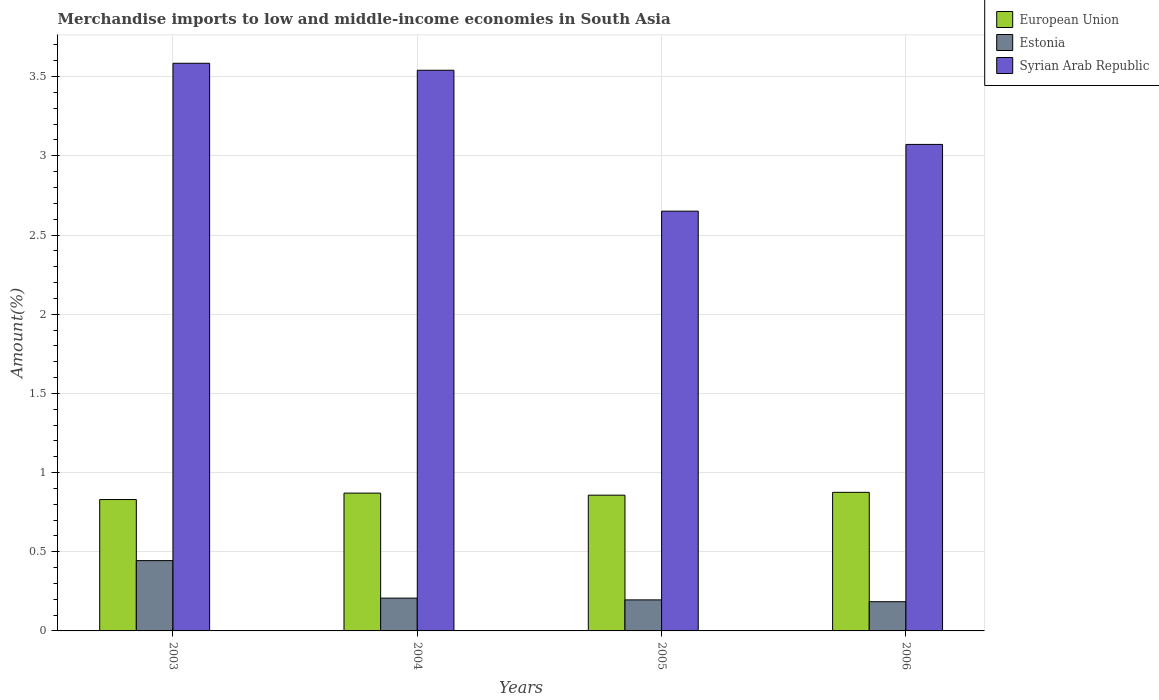Are the number of bars on each tick of the X-axis equal?
Ensure brevity in your answer.  Yes. How many bars are there on the 1st tick from the left?
Ensure brevity in your answer.  3. What is the label of the 4th group of bars from the left?
Your response must be concise. 2006. In how many cases, is the number of bars for a given year not equal to the number of legend labels?
Keep it short and to the point. 0. What is the percentage of amount earned from merchandise imports in Syrian Arab Republic in 2006?
Provide a succinct answer. 3.07. Across all years, what is the maximum percentage of amount earned from merchandise imports in Estonia?
Offer a terse response. 0.44. Across all years, what is the minimum percentage of amount earned from merchandise imports in Estonia?
Offer a terse response. 0.18. In which year was the percentage of amount earned from merchandise imports in European Union maximum?
Give a very brief answer. 2006. What is the total percentage of amount earned from merchandise imports in Estonia in the graph?
Offer a very short reply. 1.03. What is the difference between the percentage of amount earned from merchandise imports in European Union in 2003 and that in 2005?
Your answer should be very brief. -0.03. What is the difference between the percentage of amount earned from merchandise imports in Syrian Arab Republic in 2005 and the percentage of amount earned from merchandise imports in Estonia in 2006?
Keep it short and to the point. 2.47. What is the average percentage of amount earned from merchandise imports in Estonia per year?
Offer a terse response. 0.26. In the year 2005, what is the difference between the percentage of amount earned from merchandise imports in Estonia and percentage of amount earned from merchandise imports in European Union?
Give a very brief answer. -0.66. In how many years, is the percentage of amount earned from merchandise imports in European Union greater than 3.2 %?
Your answer should be compact. 0. What is the ratio of the percentage of amount earned from merchandise imports in Syrian Arab Republic in 2004 to that in 2005?
Offer a terse response. 1.34. Is the percentage of amount earned from merchandise imports in European Union in 2003 less than that in 2005?
Offer a terse response. Yes. Is the difference between the percentage of amount earned from merchandise imports in Estonia in 2003 and 2005 greater than the difference between the percentage of amount earned from merchandise imports in European Union in 2003 and 2005?
Give a very brief answer. Yes. What is the difference between the highest and the second highest percentage of amount earned from merchandise imports in Syrian Arab Republic?
Your answer should be very brief. 0.04. What is the difference between the highest and the lowest percentage of amount earned from merchandise imports in Estonia?
Your answer should be compact. 0.26. What does the 3rd bar from the left in 2005 represents?
Provide a short and direct response. Syrian Arab Republic. What does the 1st bar from the right in 2004 represents?
Provide a short and direct response. Syrian Arab Republic. Is it the case that in every year, the sum of the percentage of amount earned from merchandise imports in Estonia and percentage of amount earned from merchandise imports in European Union is greater than the percentage of amount earned from merchandise imports in Syrian Arab Republic?
Give a very brief answer. No. Are all the bars in the graph horizontal?
Provide a succinct answer. No. How many years are there in the graph?
Offer a terse response. 4. What is the difference between two consecutive major ticks on the Y-axis?
Your response must be concise. 0.5. Does the graph contain grids?
Offer a terse response. Yes. Where does the legend appear in the graph?
Your answer should be compact. Top right. How are the legend labels stacked?
Give a very brief answer. Vertical. What is the title of the graph?
Make the answer very short. Merchandise imports to low and middle-income economies in South Asia. Does "Curacao" appear as one of the legend labels in the graph?
Provide a succinct answer. No. What is the label or title of the Y-axis?
Keep it short and to the point. Amount(%). What is the Amount(%) of European Union in 2003?
Your answer should be compact. 0.83. What is the Amount(%) of Estonia in 2003?
Keep it short and to the point. 0.44. What is the Amount(%) in Syrian Arab Republic in 2003?
Your response must be concise. 3.58. What is the Amount(%) in European Union in 2004?
Give a very brief answer. 0.87. What is the Amount(%) of Estonia in 2004?
Provide a succinct answer. 0.21. What is the Amount(%) of Syrian Arab Republic in 2004?
Your answer should be compact. 3.54. What is the Amount(%) of European Union in 2005?
Give a very brief answer. 0.86. What is the Amount(%) in Estonia in 2005?
Provide a short and direct response. 0.2. What is the Amount(%) in Syrian Arab Republic in 2005?
Your response must be concise. 2.65. What is the Amount(%) in European Union in 2006?
Your answer should be compact. 0.88. What is the Amount(%) of Estonia in 2006?
Make the answer very short. 0.18. What is the Amount(%) of Syrian Arab Republic in 2006?
Provide a short and direct response. 3.07. Across all years, what is the maximum Amount(%) of European Union?
Provide a short and direct response. 0.88. Across all years, what is the maximum Amount(%) in Estonia?
Offer a very short reply. 0.44. Across all years, what is the maximum Amount(%) in Syrian Arab Republic?
Give a very brief answer. 3.58. Across all years, what is the minimum Amount(%) in European Union?
Keep it short and to the point. 0.83. Across all years, what is the minimum Amount(%) of Estonia?
Make the answer very short. 0.18. Across all years, what is the minimum Amount(%) in Syrian Arab Republic?
Ensure brevity in your answer.  2.65. What is the total Amount(%) in European Union in the graph?
Your answer should be very brief. 3.43. What is the total Amount(%) in Estonia in the graph?
Offer a very short reply. 1.03. What is the total Amount(%) of Syrian Arab Republic in the graph?
Provide a succinct answer. 12.85. What is the difference between the Amount(%) in European Union in 2003 and that in 2004?
Keep it short and to the point. -0.04. What is the difference between the Amount(%) in Estonia in 2003 and that in 2004?
Your response must be concise. 0.24. What is the difference between the Amount(%) in Syrian Arab Republic in 2003 and that in 2004?
Ensure brevity in your answer.  0.04. What is the difference between the Amount(%) of European Union in 2003 and that in 2005?
Ensure brevity in your answer.  -0.03. What is the difference between the Amount(%) in Estonia in 2003 and that in 2005?
Ensure brevity in your answer.  0.25. What is the difference between the Amount(%) in Syrian Arab Republic in 2003 and that in 2005?
Your response must be concise. 0.93. What is the difference between the Amount(%) in European Union in 2003 and that in 2006?
Provide a succinct answer. -0.05. What is the difference between the Amount(%) in Estonia in 2003 and that in 2006?
Offer a terse response. 0.26. What is the difference between the Amount(%) of Syrian Arab Republic in 2003 and that in 2006?
Your answer should be compact. 0.51. What is the difference between the Amount(%) in European Union in 2004 and that in 2005?
Your answer should be very brief. 0.01. What is the difference between the Amount(%) of Estonia in 2004 and that in 2005?
Keep it short and to the point. 0.01. What is the difference between the Amount(%) of Syrian Arab Republic in 2004 and that in 2005?
Ensure brevity in your answer.  0.89. What is the difference between the Amount(%) of European Union in 2004 and that in 2006?
Your answer should be compact. -0. What is the difference between the Amount(%) in Estonia in 2004 and that in 2006?
Offer a very short reply. 0.02. What is the difference between the Amount(%) in Syrian Arab Republic in 2004 and that in 2006?
Provide a short and direct response. 0.47. What is the difference between the Amount(%) of European Union in 2005 and that in 2006?
Your answer should be compact. -0.02. What is the difference between the Amount(%) in Estonia in 2005 and that in 2006?
Offer a very short reply. 0.01. What is the difference between the Amount(%) of Syrian Arab Republic in 2005 and that in 2006?
Make the answer very short. -0.42. What is the difference between the Amount(%) of European Union in 2003 and the Amount(%) of Estonia in 2004?
Ensure brevity in your answer.  0.62. What is the difference between the Amount(%) of European Union in 2003 and the Amount(%) of Syrian Arab Republic in 2004?
Offer a very short reply. -2.71. What is the difference between the Amount(%) of Estonia in 2003 and the Amount(%) of Syrian Arab Republic in 2004?
Your answer should be very brief. -3.1. What is the difference between the Amount(%) in European Union in 2003 and the Amount(%) in Estonia in 2005?
Your response must be concise. 0.63. What is the difference between the Amount(%) of European Union in 2003 and the Amount(%) of Syrian Arab Republic in 2005?
Provide a short and direct response. -1.82. What is the difference between the Amount(%) of Estonia in 2003 and the Amount(%) of Syrian Arab Republic in 2005?
Keep it short and to the point. -2.21. What is the difference between the Amount(%) of European Union in 2003 and the Amount(%) of Estonia in 2006?
Your response must be concise. 0.65. What is the difference between the Amount(%) of European Union in 2003 and the Amount(%) of Syrian Arab Republic in 2006?
Ensure brevity in your answer.  -2.24. What is the difference between the Amount(%) in Estonia in 2003 and the Amount(%) in Syrian Arab Republic in 2006?
Ensure brevity in your answer.  -2.63. What is the difference between the Amount(%) of European Union in 2004 and the Amount(%) of Estonia in 2005?
Keep it short and to the point. 0.67. What is the difference between the Amount(%) of European Union in 2004 and the Amount(%) of Syrian Arab Republic in 2005?
Keep it short and to the point. -1.78. What is the difference between the Amount(%) of Estonia in 2004 and the Amount(%) of Syrian Arab Republic in 2005?
Ensure brevity in your answer.  -2.44. What is the difference between the Amount(%) of European Union in 2004 and the Amount(%) of Estonia in 2006?
Provide a succinct answer. 0.69. What is the difference between the Amount(%) in European Union in 2004 and the Amount(%) in Syrian Arab Republic in 2006?
Your response must be concise. -2.2. What is the difference between the Amount(%) of Estonia in 2004 and the Amount(%) of Syrian Arab Republic in 2006?
Provide a short and direct response. -2.87. What is the difference between the Amount(%) of European Union in 2005 and the Amount(%) of Estonia in 2006?
Your response must be concise. 0.67. What is the difference between the Amount(%) of European Union in 2005 and the Amount(%) of Syrian Arab Republic in 2006?
Offer a terse response. -2.21. What is the difference between the Amount(%) of Estonia in 2005 and the Amount(%) of Syrian Arab Republic in 2006?
Your answer should be very brief. -2.88. What is the average Amount(%) in European Union per year?
Offer a very short reply. 0.86. What is the average Amount(%) of Estonia per year?
Offer a very short reply. 0.26. What is the average Amount(%) in Syrian Arab Republic per year?
Provide a succinct answer. 3.21. In the year 2003, what is the difference between the Amount(%) of European Union and Amount(%) of Estonia?
Offer a terse response. 0.39. In the year 2003, what is the difference between the Amount(%) of European Union and Amount(%) of Syrian Arab Republic?
Your response must be concise. -2.75. In the year 2003, what is the difference between the Amount(%) in Estonia and Amount(%) in Syrian Arab Republic?
Provide a short and direct response. -3.14. In the year 2004, what is the difference between the Amount(%) of European Union and Amount(%) of Estonia?
Ensure brevity in your answer.  0.66. In the year 2004, what is the difference between the Amount(%) of European Union and Amount(%) of Syrian Arab Republic?
Ensure brevity in your answer.  -2.67. In the year 2004, what is the difference between the Amount(%) of Estonia and Amount(%) of Syrian Arab Republic?
Offer a very short reply. -3.33. In the year 2005, what is the difference between the Amount(%) of European Union and Amount(%) of Estonia?
Give a very brief answer. 0.66. In the year 2005, what is the difference between the Amount(%) of European Union and Amount(%) of Syrian Arab Republic?
Your answer should be compact. -1.79. In the year 2005, what is the difference between the Amount(%) in Estonia and Amount(%) in Syrian Arab Republic?
Your response must be concise. -2.45. In the year 2006, what is the difference between the Amount(%) in European Union and Amount(%) in Estonia?
Your answer should be compact. 0.69. In the year 2006, what is the difference between the Amount(%) of European Union and Amount(%) of Syrian Arab Republic?
Make the answer very short. -2.2. In the year 2006, what is the difference between the Amount(%) in Estonia and Amount(%) in Syrian Arab Republic?
Keep it short and to the point. -2.89. What is the ratio of the Amount(%) in European Union in 2003 to that in 2004?
Ensure brevity in your answer.  0.95. What is the ratio of the Amount(%) of Estonia in 2003 to that in 2004?
Your response must be concise. 2.14. What is the ratio of the Amount(%) of Syrian Arab Republic in 2003 to that in 2004?
Ensure brevity in your answer.  1.01. What is the ratio of the Amount(%) in Estonia in 2003 to that in 2005?
Provide a succinct answer. 2.27. What is the ratio of the Amount(%) in Syrian Arab Republic in 2003 to that in 2005?
Ensure brevity in your answer.  1.35. What is the ratio of the Amount(%) of European Union in 2003 to that in 2006?
Your response must be concise. 0.95. What is the ratio of the Amount(%) of Estonia in 2003 to that in 2006?
Offer a terse response. 2.41. What is the ratio of the Amount(%) of Syrian Arab Republic in 2003 to that in 2006?
Your answer should be compact. 1.17. What is the ratio of the Amount(%) in European Union in 2004 to that in 2005?
Offer a terse response. 1.02. What is the ratio of the Amount(%) in Estonia in 2004 to that in 2005?
Make the answer very short. 1.06. What is the ratio of the Amount(%) of Syrian Arab Republic in 2004 to that in 2005?
Give a very brief answer. 1.34. What is the ratio of the Amount(%) of European Union in 2004 to that in 2006?
Provide a short and direct response. 0.99. What is the ratio of the Amount(%) in Estonia in 2004 to that in 2006?
Provide a succinct answer. 1.12. What is the ratio of the Amount(%) of Syrian Arab Republic in 2004 to that in 2006?
Ensure brevity in your answer.  1.15. What is the ratio of the Amount(%) in European Union in 2005 to that in 2006?
Offer a terse response. 0.98. What is the ratio of the Amount(%) of Estonia in 2005 to that in 2006?
Your answer should be compact. 1.06. What is the ratio of the Amount(%) in Syrian Arab Republic in 2005 to that in 2006?
Offer a very short reply. 0.86. What is the difference between the highest and the second highest Amount(%) in European Union?
Make the answer very short. 0. What is the difference between the highest and the second highest Amount(%) of Estonia?
Provide a short and direct response. 0.24. What is the difference between the highest and the second highest Amount(%) in Syrian Arab Republic?
Offer a very short reply. 0.04. What is the difference between the highest and the lowest Amount(%) in European Union?
Provide a short and direct response. 0.05. What is the difference between the highest and the lowest Amount(%) of Estonia?
Provide a succinct answer. 0.26. What is the difference between the highest and the lowest Amount(%) of Syrian Arab Republic?
Offer a terse response. 0.93. 